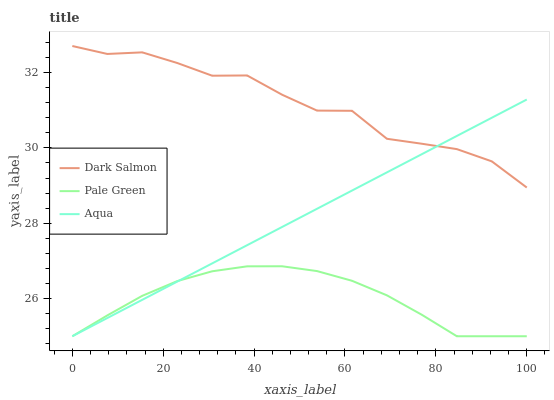Does Pale Green have the minimum area under the curve?
Answer yes or no. Yes. Does Dark Salmon have the maximum area under the curve?
Answer yes or no. Yes. Does Aqua have the minimum area under the curve?
Answer yes or no. No. Does Aqua have the maximum area under the curve?
Answer yes or no. No. Is Aqua the smoothest?
Answer yes or no. Yes. Is Dark Salmon the roughest?
Answer yes or no. Yes. Is Dark Salmon the smoothest?
Answer yes or no. No. Is Aqua the roughest?
Answer yes or no. No. Does Pale Green have the lowest value?
Answer yes or no. Yes. Does Dark Salmon have the lowest value?
Answer yes or no. No. Does Dark Salmon have the highest value?
Answer yes or no. Yes. Does Aqua have the highest value?
Answer yes or no. No. Is Pale Green less than Dark Salmon?
Answer yes or no. Yes. Is Dark Salmon greater than Pale Green?
Answer yes or no. Yes. Does Aqua intersect Dark Salmon?
Answer yes or no. Yes. Is Aqua less than Dark Salmon?
Answer yes or no. No. Is Aqua greater than Dark Salmon?
Answer yes or no. No. Does Pale Green intersect Dark Salmon?
Answer yes or no. No. 